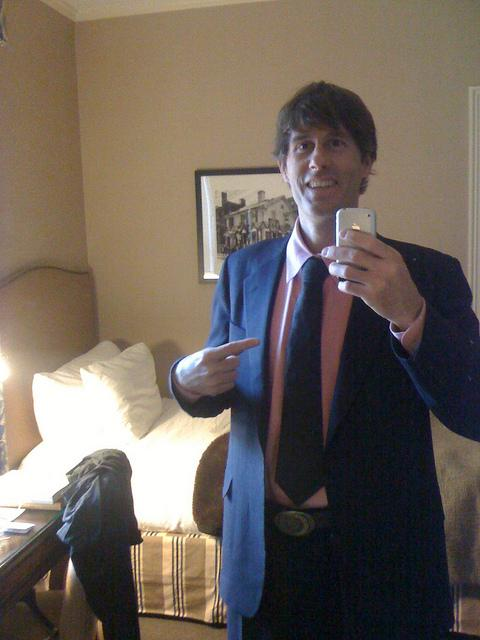What is the man doing? Please explain your reasoning. pointing. He has his finger out straight aimed at his tie 